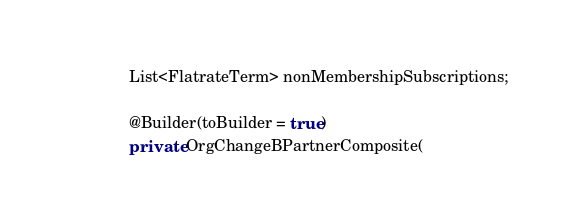Convert code to text. <code><loc_0><loc_0><loc_500><loc_500><_Java_>	List<FlatrateTerm> nonMembershipSubscriptions;

	@Builder(toBuilder = true)
	private OrgChangeBPartnerComposite(</code> 